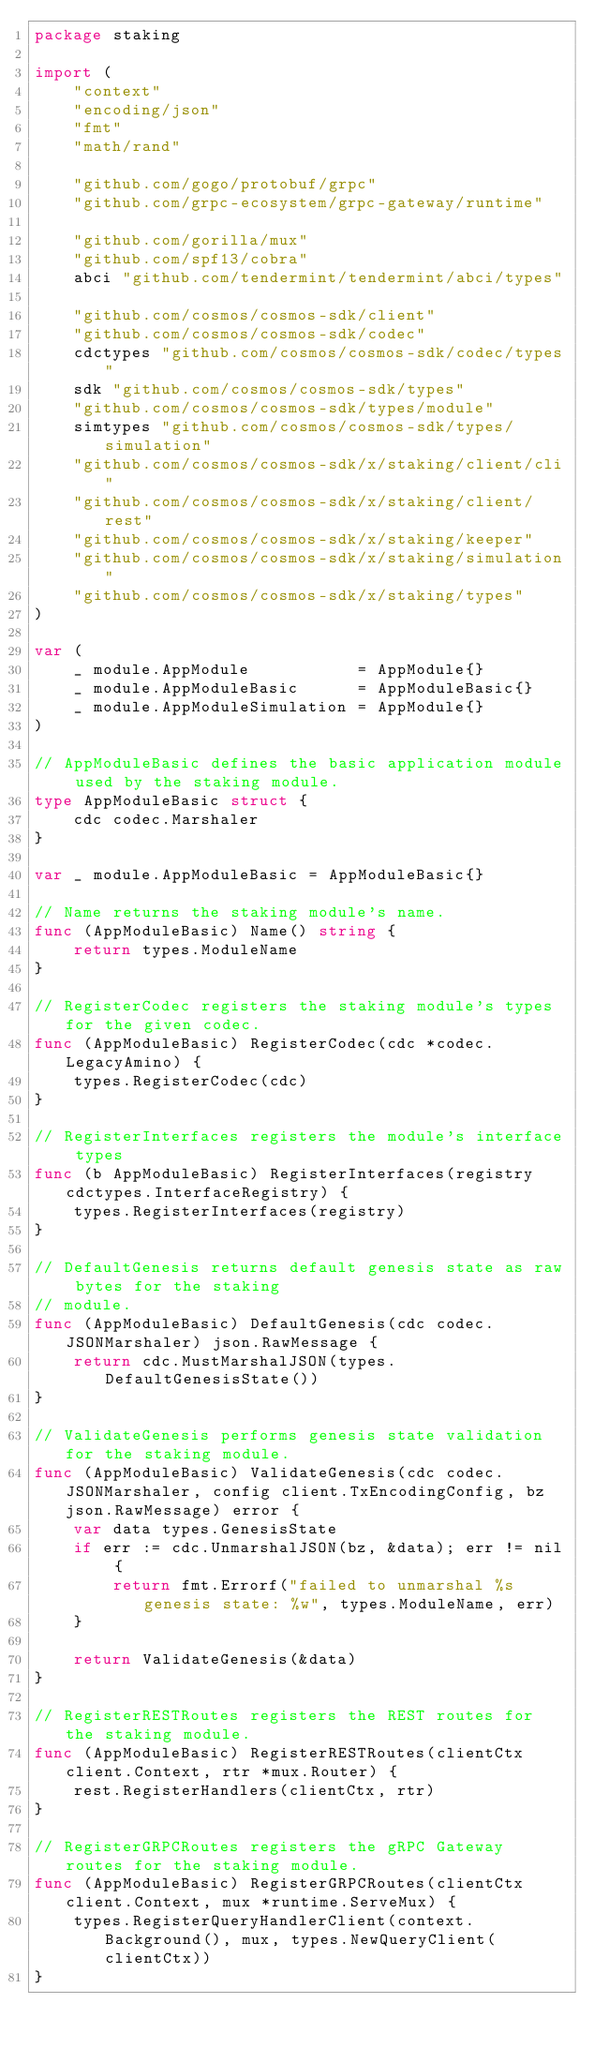<code> <loc_0><loc_0><loc_500><loc_500><_Go_>package staking

import (
	"context"
	"encoding/json"
	"fmt"
	"math/rand"

	"github.com/gogo/protobuf/grpc"
	"github.com/grpc-ecosystem/grpc-gateway/runtime"

	"github.com/gorilla/mux"
	"github.com/spf13/cobra"
	abci "github.com/tendermint/tendermint/abci/types"

	"github.com/cosmos/cosmos-sdk/client"
	"github.com/cosmos/cosmos-sdk/codec"
	cdctypes "github.com/cosmos/cosmos-sdk/codec/types"
	sdk "github.com/cosmos/cosmos-sdk/types"
	"github.com/cosmos/cosmos-sdk/types/module"
	simtypes "github.com/cosmos/cosmos-sdk/types/simulation"
	"github.com/cosmos/cosmos-sdk/x/staking/client/cli"
	"github.com/cosmos/cosmos-sdk/x/staking/client/rest"
	"github.com/cosmos/cosmos-sdk/x/staking/keeper"
	"github.com/cosmos/cosmos-sdk/x/staking/simulation"
	"github.com/cosmos/cosmos-sdk/x/staking/types"
)

var (
	_ module.AppModule           = AppModule{}
	_ module.AppModuleBasic      = AppModuleBasic{}
	_ module.AppModuleSimulation = AppModule{}
)

// AppModuleBasic defines the basic application module used by the staking module.
type AppModuleBasic struct {
	cdc codec.Marshaler
}

var _ module.AppModuleBasic = AppModuleBasic{}

// Name returns the staking module's name.
func (AppModuleBasic) Name() string {
	return types.ModuleName
}

// RegisterCodec registers the staking module's types for the given codec.
func (AppModuleBasic) RegisterCodec(cdc *codec.LegacyAmino) {
	types.RegisterCodec(cdc)
}

// RegisterInterfaces registers the module's interface types
func (b AppModuleBasic) RegisterInterfaces(registry cdctypes.InterfaceRegistry) {
	types.RegisterInterfaces(registry)
}

// DefaultGenesis returns default genesis state as raw bytes for the staking
// module.
func (AppModuleBasic) DefaultGenesis(cdc codec.JSONMarshaler) json.RawMessage {
	return cdc.MustMarshalJSON(types.DefaultGenesisState())
}

// ValidateGenesis performs genesis state validation for the staking module.
func (AppModuleBasic) ValidateGenesis(cdc codec.JSONMarshaler, config client.TxEncodingConfig, bz json.RawMessage) error {
	var data types.GenesisState
	if err := cdc.UnmarshalJSON(bz, &data); err != nil {
		return fmt.Errorf("failed to unmarshal %s genesis state: %w", types.ModuleName, err)
	}

	return ValidateGenesis(&data)
}

// RegisterRESTRoutes registers the REST routes for the staking module.
func (AppModuleBasic) RegisterRESTRoutes(clientCtx client.Context, rtr *mux.Router) {
	rest.RegisterHandlers(clientCtx, rtr)
}

// RegisterGRPCRoutes registers the gRPC Gateway routes for the staking module.
func (AppModuleBasic) RegisterGRPCRoutes(clientCtx client.Context, mux *runtime.ServeMux) {
	types.RegisterQueryHandlerClient(context.Background(), mux, types.NewQueryClient(clientCtx))
}
</code> 